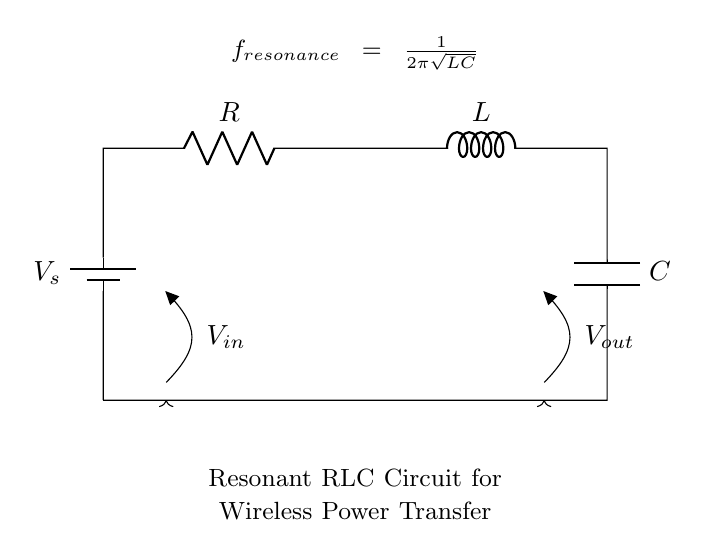What are the components in this circuit? The circuit contains a voltage source, resistor, inductor, and capacitor. The diagram clearly labels each component, making it easy to identify them.
Answer: Voltage source, resistor, inductor, capacitor What is the function of the capacitor in this circuit? The capacitor in this circuit serves to store energy and create resonant behavior with the inductor. This enables efficient wireless power transfer at a specific resonant frequency determined by the circuit's L and C values.
Answer: Store energy and create resonance What is the formula for resonant frequency shown in the circuit? The diagram displays the resonant frequency formula, which is f_resonance = 1/(2π√(LC)). This indicates how the frequency at which the circuit operates depends on the inductance and capacitance values.
Answer: f_resonance = 1/(2π√(LC)) What happens to the circuit's response if the resistance increases? Increasing the resistance generally results in a decrease in the quality factor (Q) of the circuit, leading to a broader resonance curve and less efficient energy transfer. This connection is established by examining the relationship between resistance and energy dissipation in the circuit.
Answer: Decreased quality factor and less efficient energy transfer How does this RLC circuit achieve resonance? This RLC circuit achieves resonance when the inductive reactance equals the capacitive reactance at a specific frequency, allowing maximum current to flow through the circuit. The formula provided in the diagram indicates the mathematical relationship that defines this frequency.
Answer: Inductive reactance equals capacitive reactance What is the significance of the voltage nodes labeled V_in and V_out? The voltage nodes V_in and V_out indicate where the input voltage is applied to the circuit and where the output voltage is measured. V_in represents the supply voltage from the source, while V_out refers to the voltage across the load that will receive power wirelessly.
Answer: Input and output voltage references 